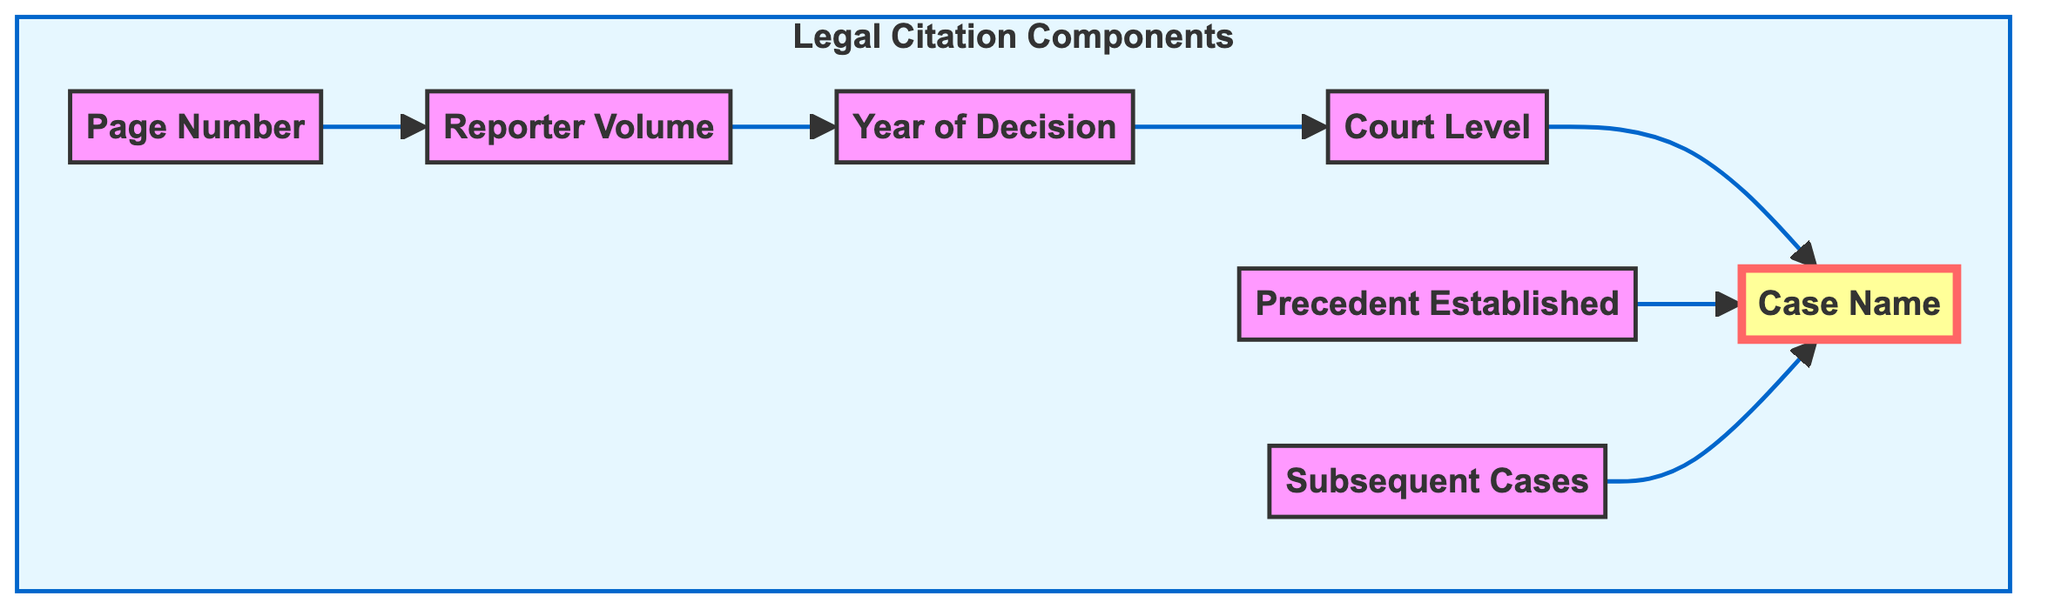What is the top node in the flowchart? The top node in the flowchart represents the primary element of the diagram, which is the case name. In this diagram, the case name serves as the central component, linking multiple aspects of the legal citation together.
Answer: Case Name How many components are present in the legal citation? The legal citation consists of seven components, including the case name, court level, year of decision, reporter volume, page number, precedent, and subsequent cases. The flowchart explicitly lists these components.
Answer: Seven Which node directly leads to the case name? In the diagram, both the precedent and subsequent cases nodes have direct arrows pointing to the case name. This indicates that they both are relevant to the case itself.
Answer: Precedent, Subsequent Cases What follows the page number in the diagram? According to the flowchart, the page number is followed by the reporter volume. The arrow connects these two nodes, meaning the page number leads to the reporter volume for further citation detail.
Answer: Reporter Volume What is the relationship between the citation year and the court level? The citation year is directly linked to the court level node, indicating that the year of the decision influences or relates to the level of court that made the decision. The flow flows from citation year to court level.
Answer: Direct link Which component is the last in the flow sequence? In the bottom-up flow sequence of the diagram, there is no node that follows the case name; therefore, the case name is the last node in the flow. It serves as the culmination of the citation breakdown.
Answer: Case Name What links the court level and case name? The court level is linked to the case name through a direct arrow in the flowchart, indicating that the court level informs or is associated with the case name. This relationship indicates a connection between where the case was adjudicated and its identification.
Answer: Direct arrow Which components establish precedents? The component that establishes precedents is labeled as "Precedent Established," which refers to doctrinal changes or legal principles introduced by a specific case. This node shows how a case influences future legal understanding and application.
Answer: Precedent Established 